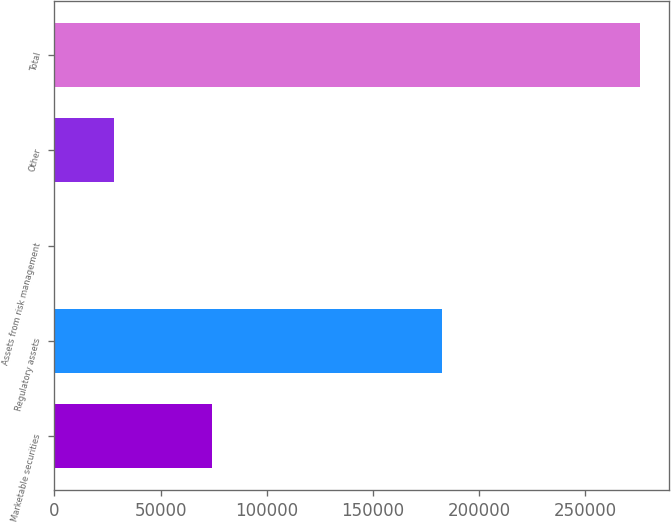<chart> <loc_0><loc_0><loc_500><loc_500><bar_chart><fcel>Marketable securities<fcel>Regulatory assets<fcel>Assets from risk management<fcel>Other<fcel>Total<nl><fcel>74200<fcel>182573<fcel>368<fcel>27879.6<fcel>275484<nl></chart> 